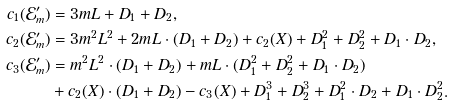<formula> <loc_0><loc_0><loc_500><loc_500>c _ { 1 } ( \mathcal { E } _ { m } ^ { \prime } ) & = 3 m L + D _ { 1 } + D _ { 2 } , \\ c _ { 2 } ( \mathcal { E } _ { m } ^ { \prime } ) & = 3 m ^ { 2 } L ^ { 2 } + 2 m L \cdot ( D _ { 1 } + D _ { 2 } ) + c _ { 2 } ( X ) + D _ { 1 } ^ { 2 } + D _ { 2 } ^ { 2 } + D _ { 1 } \cdot D _ { 2 } , \\ c _ { 3 } ( \mathcal { E } _ { m } ^ { \prime } ) & = m ^ { 2 } L ^ { 2 } \cdot ( D _ { 1 } + D _ { 2 } ) + m L \cdot ( D _ { 1 } ^ { 2 } + D _ { 2 } ^ { 2 } + D _ { 1 } \cdot D _ { 2 } ) \\ & + c _ { 2 } ( X ) \cdot ( D _ { 1 } + D _ { 2 } ) - c _ { 3 } ( X ) + D _ { 1 } ^ { 3 } + D _ { 2 } ^ { 3 } + D _ { 1 } ^ { 2 } \cdot D _ { 2 } + D _ { 1 } \cdot D _ { 2 } ^ { 2 } .</formula> 